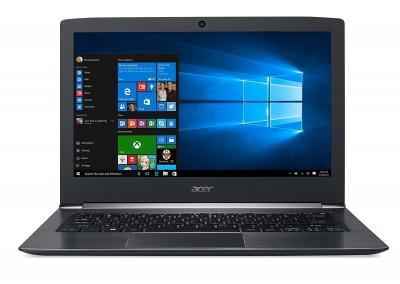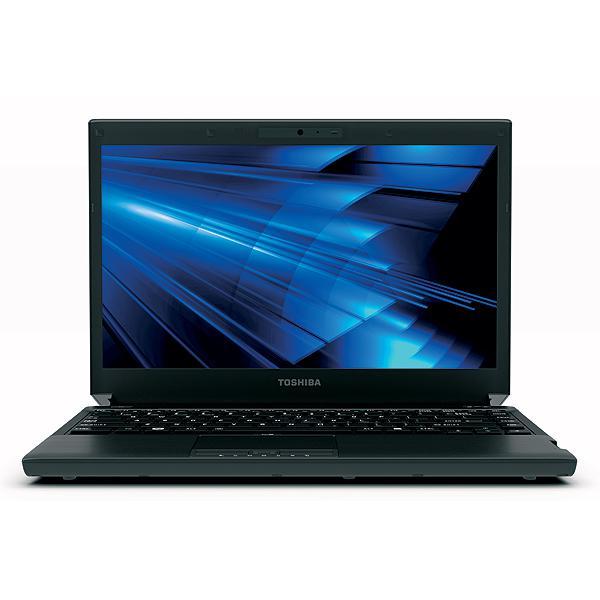The first image is the image on the left, the second image is the image on the right. Given the left and right images, does the statement "The open laptop on the left is viewed head-on, and the open laptop on the right is displayed at an angle." hold true? Answer yes or no. No. The first image is the image on the left, the second image is the image on the right. Analyze the images presented: Is the assertion "The computer displays have the same background image." valid? Answer yes or no. No. 